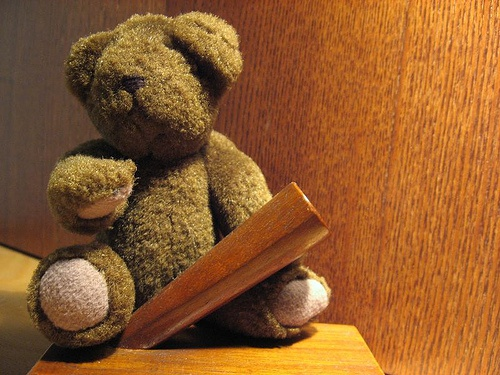Describe the objects in this image and their specific colors. I can see a teddy bear in black, maroon, and olive tones in this image. 